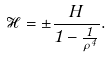Convert formula to latex. <formula><loc_0><loc_0><loc_500><loc_500>\mathcal { H } = \pm \frac { H } { 1 - \frac { 1 } { \rho ^ { 4 } } } .</formula> 